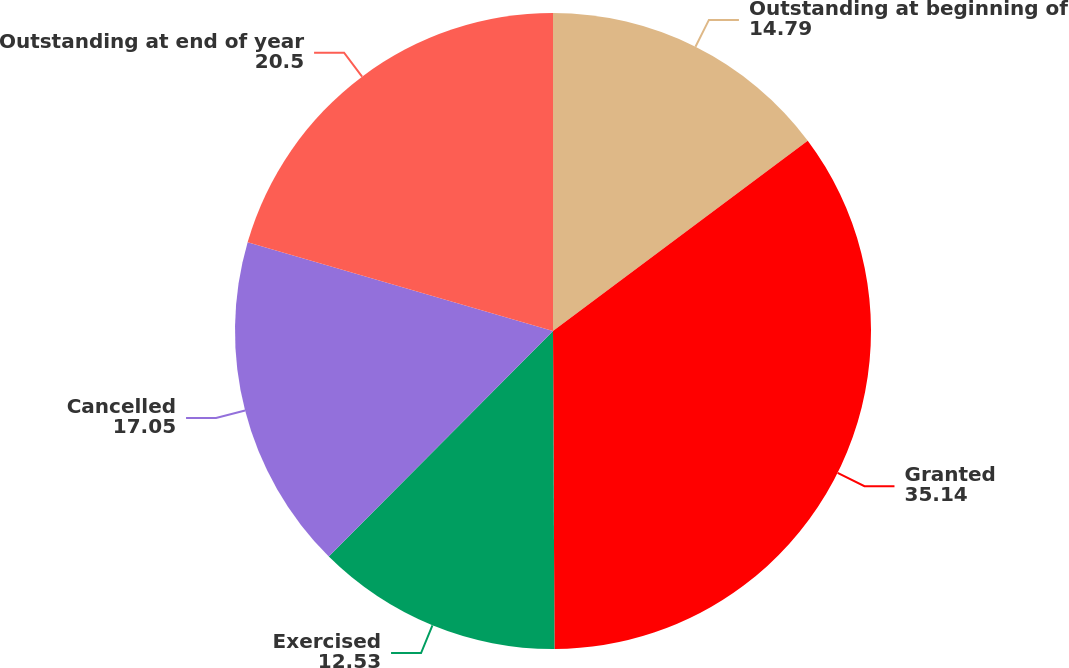Convert chart. <chart><loc_0><loc_0><loc_500><loc_500><pie_chart><fcel>Outstanding at beginning of<fcel>Granted<fcel>Exercised<fcel>Cancelled<fcel>Outstanding at end of year<nl><fcel>14.79%<fcel>35.14%<fcel>12.53%<fcel>17.05%<fcel>20.5%<nl></chart> 